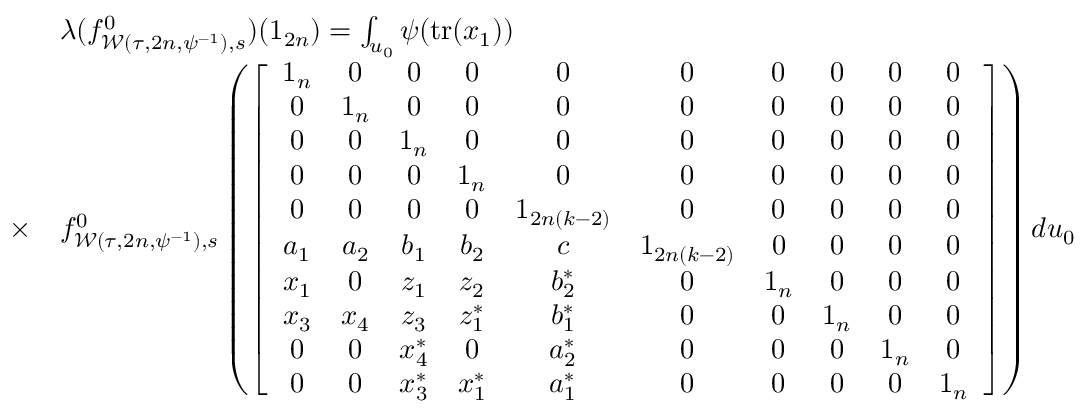<formula> <loc_0><loc_0><loc_500><loc_500>\begin{array} { r l } & { \lambda ( f _ { \mathcal { W } ( \tau , 2 n , \psi ^ { - 1 } ) , s } ^ { 0 } ) ( 1 _ { 2 n } ) = \int _ { u _ { 0 } } \psi ( t r ( x _ { 1 } ) ) } \\ { \times } & { f _ { \mathcal { W } ( \tau , 2 n , \psi ^ { - 1 } ) , s } ^ { 0 } \left ( \left [ \begin{array} { c c c c c c c c c c } { 1 _ { n } } & { 0 } & { 0 } & { 0 } & { 0 } & { 0 } & { 0 } & { 0 } & { 0 } & { 0 } \\ { 0 } & { 1 _ { n } } & { 0 } & { 0 } & { 0 } & { 0 } & { 0 } & { 0 } & { 0 } & { 0 } \\ { 0 } & { 0 } & { 1 _ { n } } & { 0 } & { 0 } & { 0 } & { 0 } & { 0 } & { 0 } & { 0 } \\ { 0 } & { 0 } & { 0 } & { 1 _ { n } } & { 0 } & { 0 } & { 0 } & { 0 } & { 0 } & { 0 } \\ { 0 } & { 0 } & { 0 } & { 0 } & { 1 _ { 2 n ( k - 2 ) } } & { 0 } & { 0 } & { 0 } & { 0 } & { 0 } \\ { a _ { 1 } } & { a _ { 2 } } & { b _ { 1 } } & { b _ { 2 } } & { c } & { 1 _ { 2 n ( k - 2 ) } } & { 0 } & { 0 } & { 0 } & { 0 } \\ { x _ { 1 } } & { 0 } & { z _ { 1 } } & { z _ { 2 } } & { b _ { 2 } ^ { \ast } } & { 0 } & { 1 _ { n } } & { 0 } & { 0 } & { 0 } \\ { x _ { 3 } } & { x _ { 4 } } & { z _ { 3 } } & { z _ { 1 } ^ { \ast } } & { b _ { 1 } ^ { \ast } } & { 0 } & { 0 } & { 1 _ { n } } & { 0 } & { 0 } \\ { 0 } & { 0 } & { x _ { 4 } ^ { \ast } } & { 0 } & { a _ { 2 } ^ { \ast } } & { 0 } & { 0 } & { 0 } & { 1 _ { n } } & { 0 } \\ { 0 } & { 0 } & { x _ { 3 } ^ { \ast } } & { x _ { 1 } ^ { \ast } } & { a _ { 1 } ^ { \ast } } & { 0 } & { 0 } & { 0 } & { 0 } & { 1 _ { n } } \end{array} \right ] \right ) d u _ { 0 } } \end{array}</formula> 